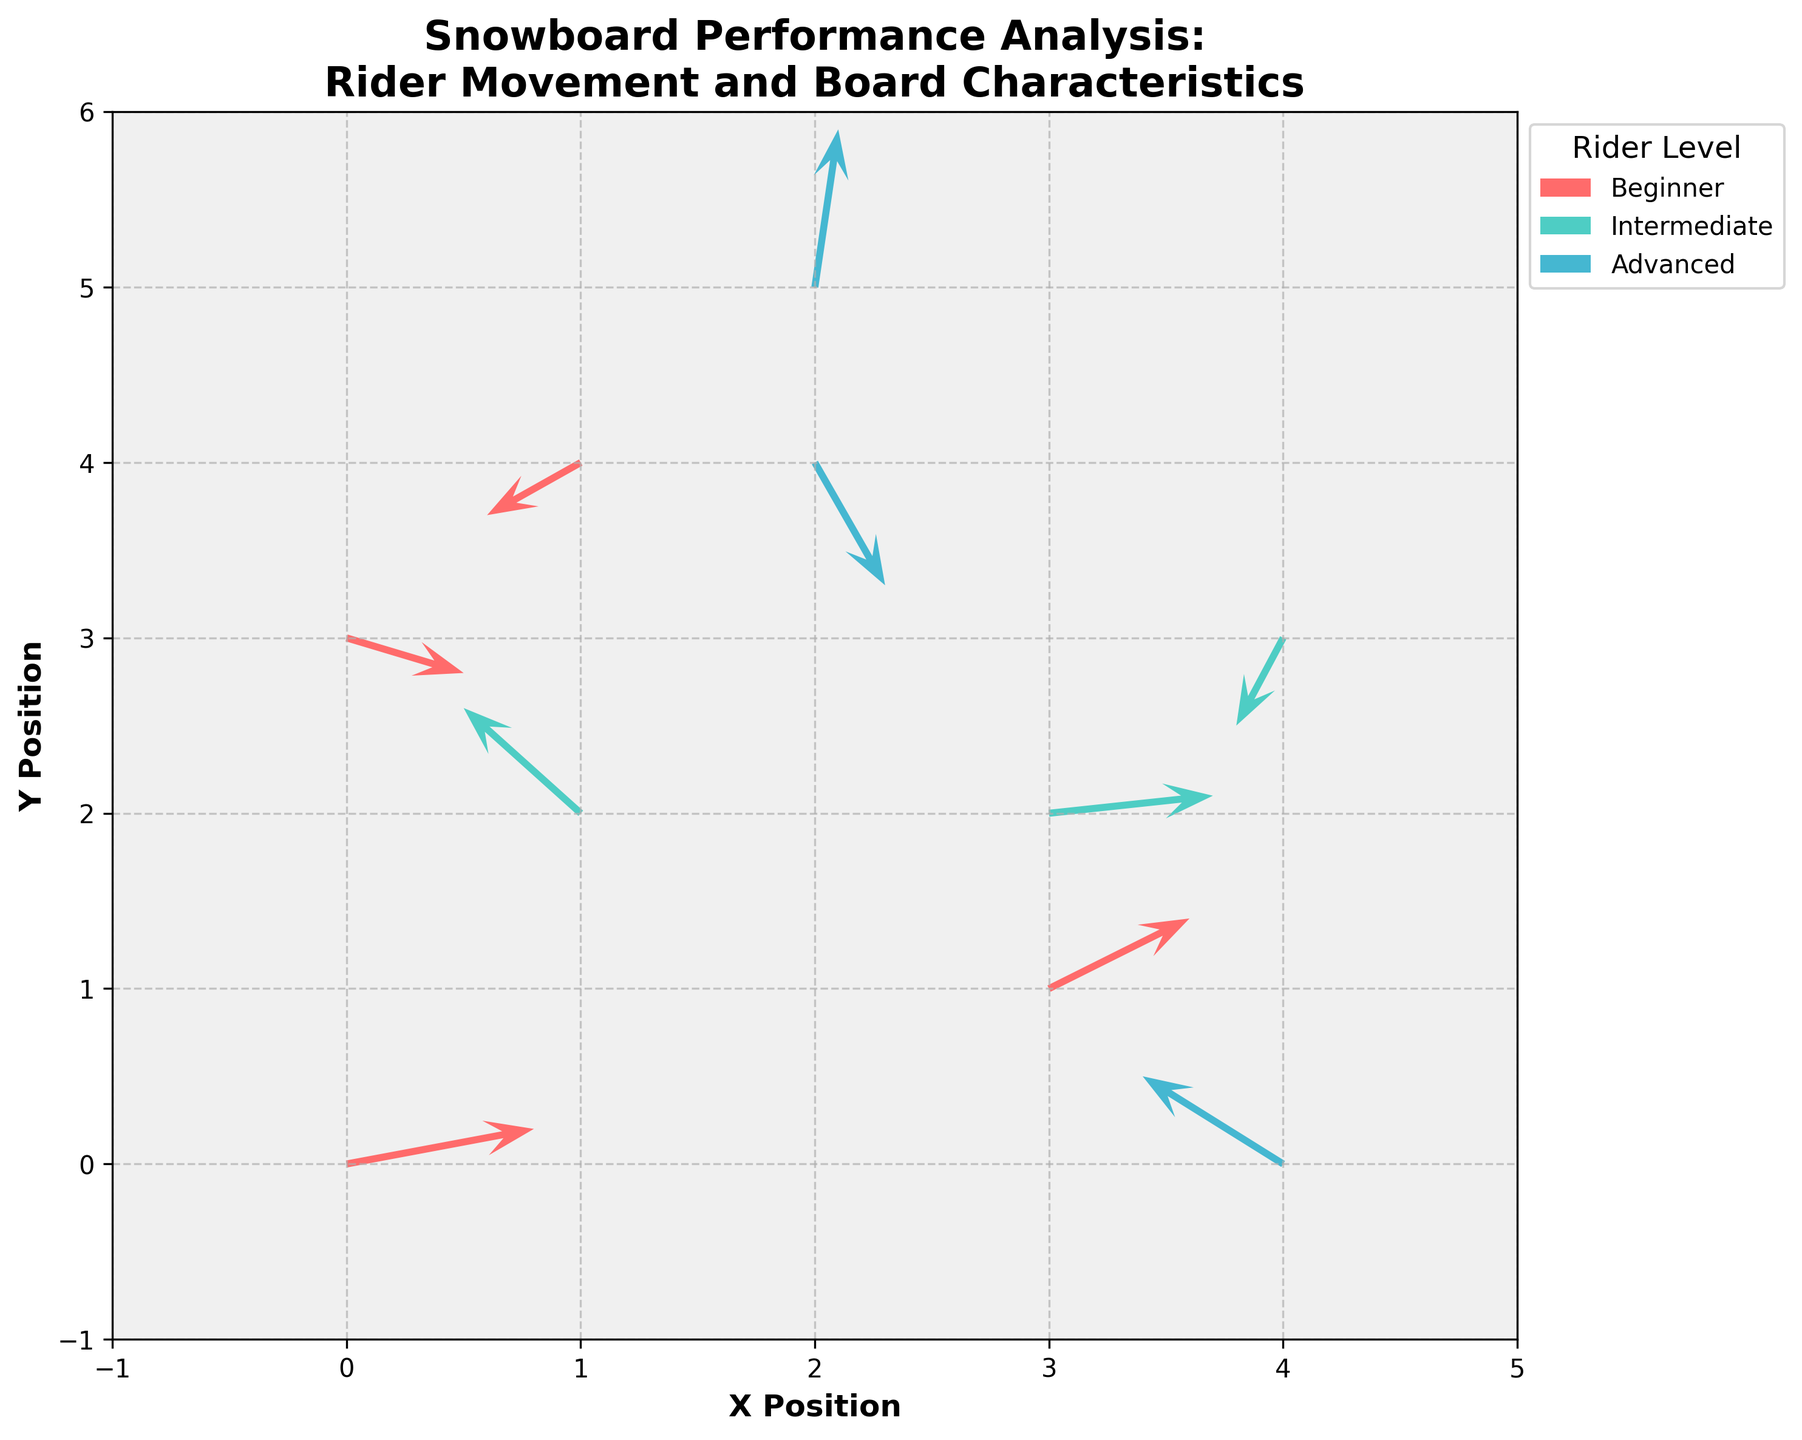What is the title of the figure? The title is usually found at the top of the figure and is often in a larger or bolder font compared to other text. In this case, it clearly states the purpose of the visual: "Snowboard Performance Analysis:\nRider Movement and Board Characteristics"
Answer: Snowboard Performance Analysis:\nRider Movement and Board Characteristics What are the x and y-axis labels? The axis labels are typically located beside the ticks along the axes. Here, the x-axis is labeled "X Position" and the y-axis is labeled "Y Position."
Answer: X Position, Y Position How many data points are there for each rider level? We count the number of arrows (quiver points) color-coded by the legend. Beginner has 4 points, Intermediate has 3 points, and Advanced has 3 points.
Answer: Beginner: 4, Intermediate: 3, Advanced: 3 Which rider level shows movement towards the left on average? From the direction of the arrows: Intermediate has two arrows with negative u values (leftward direction), Beginner has one, and Advanced has one. Therefore, Intermediate shows more leftward movement.
Answer: Intermediate Which rider level has the most vertical movement? By observing the length of the vertical vectors (v component), Advanced riders have some of the longest vertical arrows. It's most evident in their larger positive and negative v values.
Answer: Advanced What's the total vertical movement (sum of v values) for Beginner riders? Adding up the v components of the Beginner riders: 0.2 + 0.4 - 0.3 - 0.2 = 0.1.
Answer: 0.1 Compare the horizontal movement of Intermediate and Advanced riders. Who moves more to the right? Summing the u components: Intermediate: -0.5 - 0.2 + 0.7 = 0.0. Advanced: 0.3 + 0.1 - 0.6 = -0.2. Intermediate has more rightward (positive u) or balanced movement compared to Advanced.
Answer: Intermediate Which data point has the highest upward movement and which rider level does it belong to? The highest upward movement is denoted by the maximum positive v value. Here, it's 0.9 in point (2, 5), which belongs to an Advanced rider.
Answer: (2, 5), Advanced How many grid lines are visible on the y-axis? Counting the horizontal grid lines from the -1 position to the 6 position on the y-axis, gives a total of 7 grid lines.
Answer: 7 